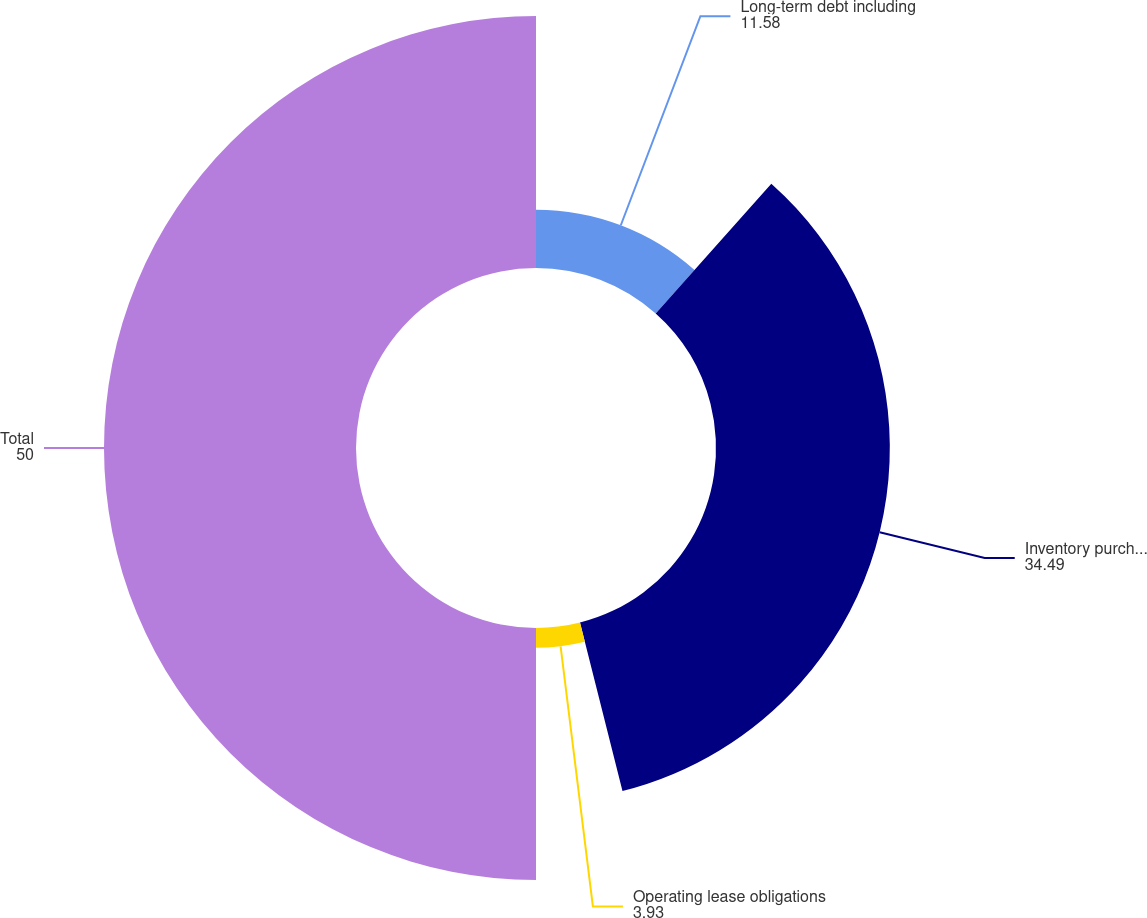<chart> <loc_0><loc_0><loc_500><loc_500><pie_chart><fcel>Long-term debt including<fcel>Inventory purchase commitments<fcel>Operating lease obligations<fcel>Total<nl><fcel>11.58%<fcel>34.49%<fcel>3.93%<fcel>50.0%<nl></chart> 